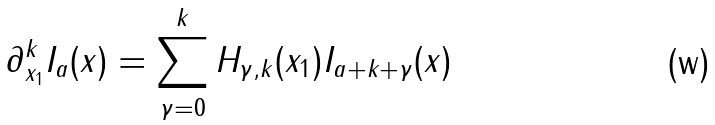Convert formula to latex. <formula><loc_0><loc_0><loc_500><loc_500>\partial _ { x _ { 1 } } ^ { k } I _ { a } ( x ) = \sum _ { \gamma = 0 } ^ { k } H _ { \gamma , k } ( x _ { 1 } ) I _ { a + k + \gamma } ( x )</formula> 